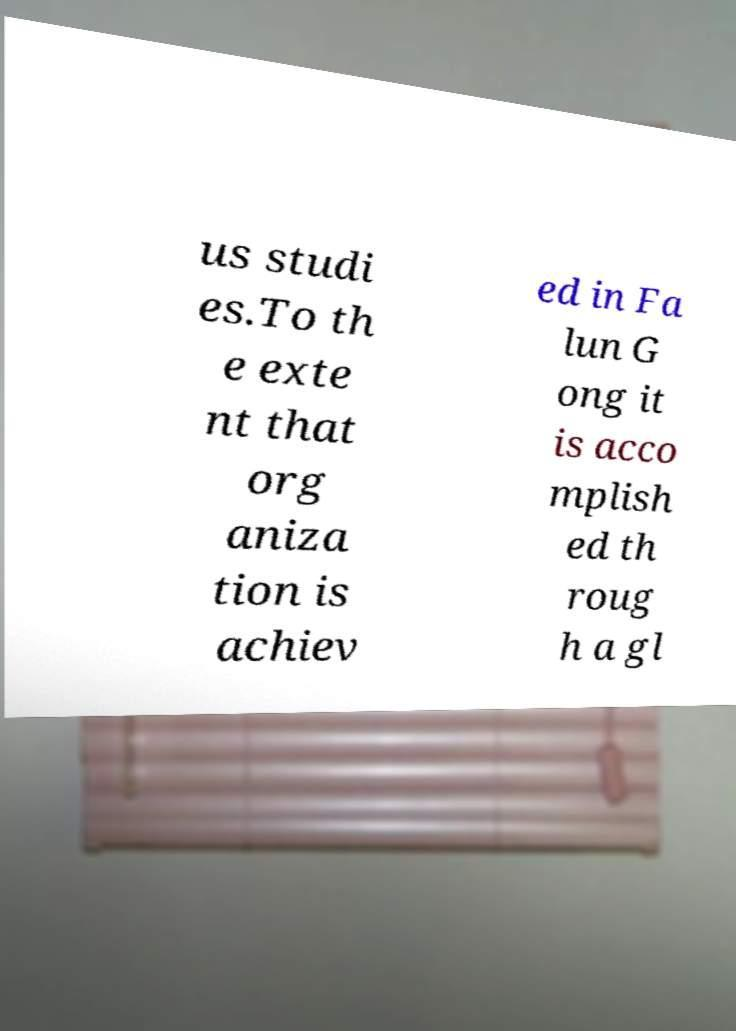Can you read and provide the text displayed in the image?This photo seems to have some interesting text. Can you extract and type it out for me? us studi es.To th e exte nt that org aniza tion is achiev ed in Fa lun G ong it is acco mplish ed th roug h a gl 